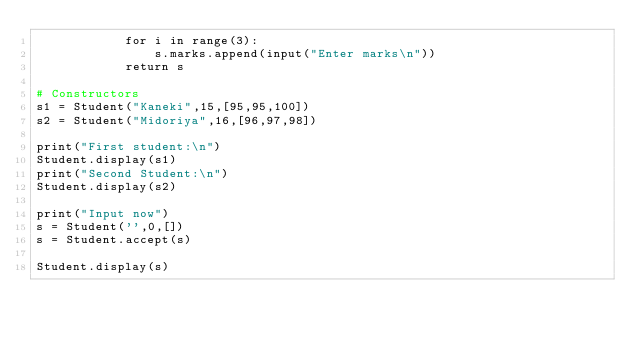<code> <loc_0><loc_0><loc_500><loc_500><_Python_>            for i in range(3):
                s.marks.append(input("Enter marks\n"))
            return s

# Constructors
s1 = Student("Kaneki",15,[95,95,100])
s2 = Student("Midoriya",16,[96,97,98])

print("First student:\n")
Student.display(s1)
print("Second Student:\n")
Student.display(s2)

print("Input now")
s = Student('',0,[])
s = Student.accept(s)

Student.display(s)
</code> 